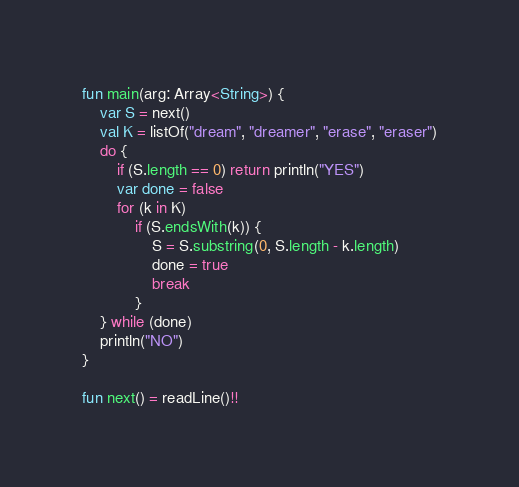<code> <loc_0><loc_0><loc_500><loc_500><_Kotlin_>fun main(arg: Array<String>) {
    var S = next()
    val K = listOf("dream", "dreamer", "erase", "eraser")
    do {
        if (S.length == 0) return println("YES")
        var done = false
        for (k in K)
            if (S.endsWith(k)) {
                S = S.substring(0, S.length - k.length)
                done = true
                break
            }
    } while (done)
    println("NO")
}

fun next() = readLine()!!
</code> 